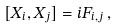Convert formula to latex. <formula><loc_0><loc_0><loc_500><loc_500>[ X _ { i } , X _ { j } ] = i F _ { i , j } \, ,</formula> 